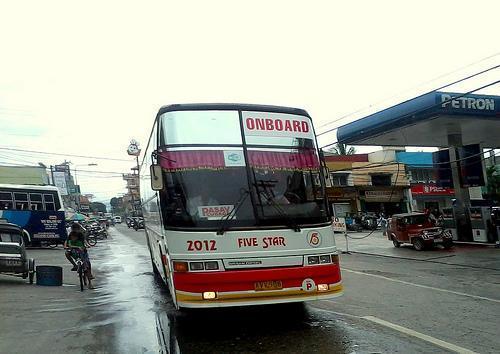How many people are riding the bike on the left?
Give a very brief answer. 2. 